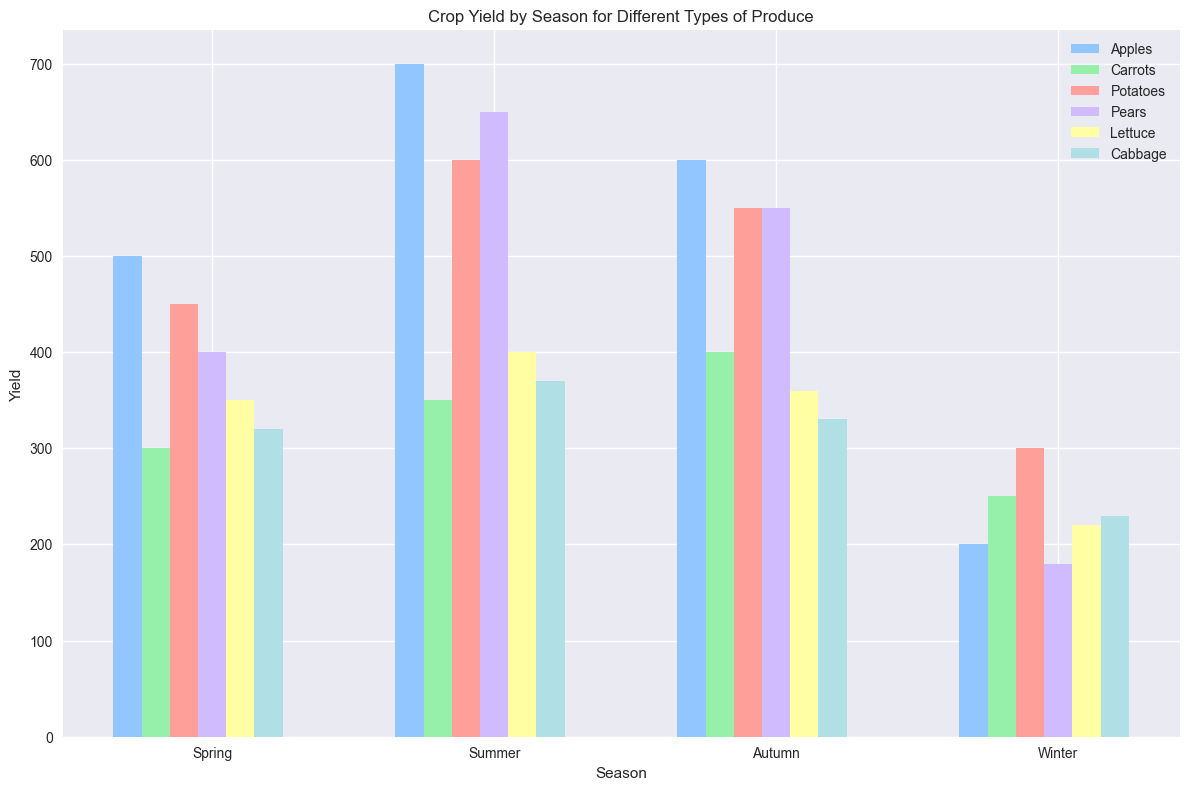Which season has the highest yield of Apples? Look at the height of the bars representing Apples for each season. The tallest bar for Apples is in the Summer.
Answer: Summer What is the yield difference between Summer and Winter for Potatoes? Identify the bar heights for Potatoes in Summer and Winter. The yield in Summer is 600 and in Winter is 300. The difference is 600 - 300 = 300.
Answer: 300 Which produce type has the highest yield in Autumn? Compare the heights of all bars for each produce type in Autumn. The highest yield is for Apples with a height of 600.
Answer: Apples What's the average yield of Lettuce across all seasons? Sum the yields of Lettuce in all the seasons: 350 (Spring) + 400 (Summer) + 360 (Autumn) + 220 (Winter) = 1330. Divide by the number of seasons (4): 1330 / 4 = 332.5.
Answer: 332.5 Compare the yields of Carrots and Potatoes in Spring. Which one is higher and by how much? Identify the bar heights for Carrots and Potatoes in Spring. Carrots yield 300 and Potatoes yield 450. The difference is 450 - 300 = 150. Potatoes have a higher yield.
Answer: Potatoes, 150 What is the total yield of Pears across all seasons? Sum the yields of Pears in all the seasons: 400 (Spring) + 650 (Summer) + 550 (Autumn) + 180 (Winter) = 1780.
Answer: 1780 Which season shows the lowest yield for Cabbage? Compare the bar heights for Cabbage across all seasons. The shortest bar is in Winter with a yield of 230.
Answer: Winter What is the yield difference between Spring and Autumn for Carrots? Identify the bar heights for Carrots in Spring and Autumn. The yield in Spring is 300 and in Autumn is 400. The difference is 400 - 300 = 100.
Answer: 100 Which produce has the largest variation in yield across seasons? Observe the range of bar heights for each produce type across all seasons. Apples show the largest variation from 200 (Winter) to 700 (Summer), a range of 500.
Answer: Apples 